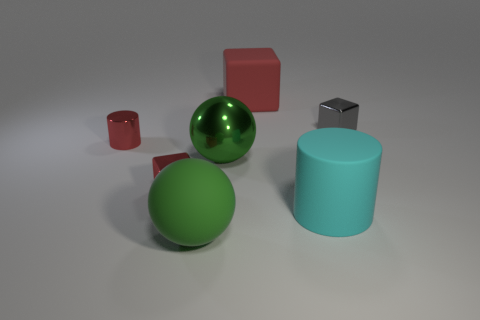Are there any small red objects that have the same material as the small cylinder?
Provide a succinct answer. Yes. Do the gray object and the tiny red cylinder have the same material?
Offer a terse response. Yes. What is the color of the metal object that is the same size as the green rubber sphere?
Offer a terse response. Green. How many other things are there of the same shape as the big red matte object?
Make the answer very short. 2. There is a gray block; does it have the same size as the red object that is behind the tiny metal cylinder?
Offer a very short reply. No. How many objects are big shiny spheres or tiny gray shiny blocks?
Ensure brevity in your answer.  2. How many other objects are there of the same size as the green shiny ball?
Your answer should be very brief. 3. There is a big metallic thing; is it the same color as the small metal block that is behind the green shiny ball?
Provide a succinct answer. No. What number of cylinders are small red things or large cyan objects?
Provide a short and direct response. 2. Are there any other things of the same color as the big metal object?
Keep it short and to the point. Yes. 